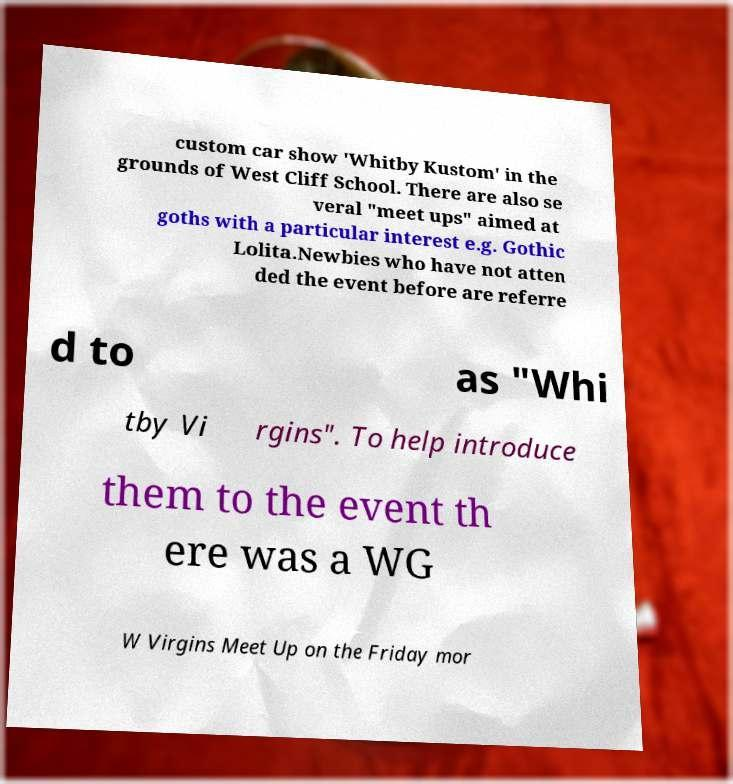Could you assist in decoding the text presented in this image and type it out clearly? custom car show 'Whitby Kustom' in the grounds of West Cliff School. There are also se veral "meet ups" aimed at goths with a particular interest e.g. Gothic Lolita.Newbies who have not atten ded the event before are referre d to as "Whi tby Vi rgins". To help introduce them to the event th ere was a WG W Virgins Meet Up on the Friday mor 